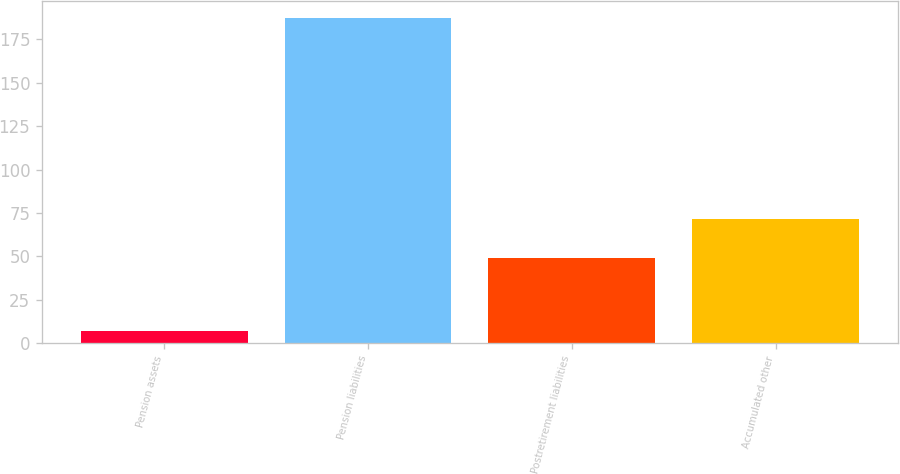Convert chart to OTSL. <chart><loc_0><loc_0><loc_500><loc_500><bar_chart><fcel>Pension assets<fcel>Pension liabilities<fcel>Postretirement liabilities<fcel>Accumulated other<nl><fcel>6.9<fcel>187.6<fcel>49.1<fcel>71.7<nl></chart> 